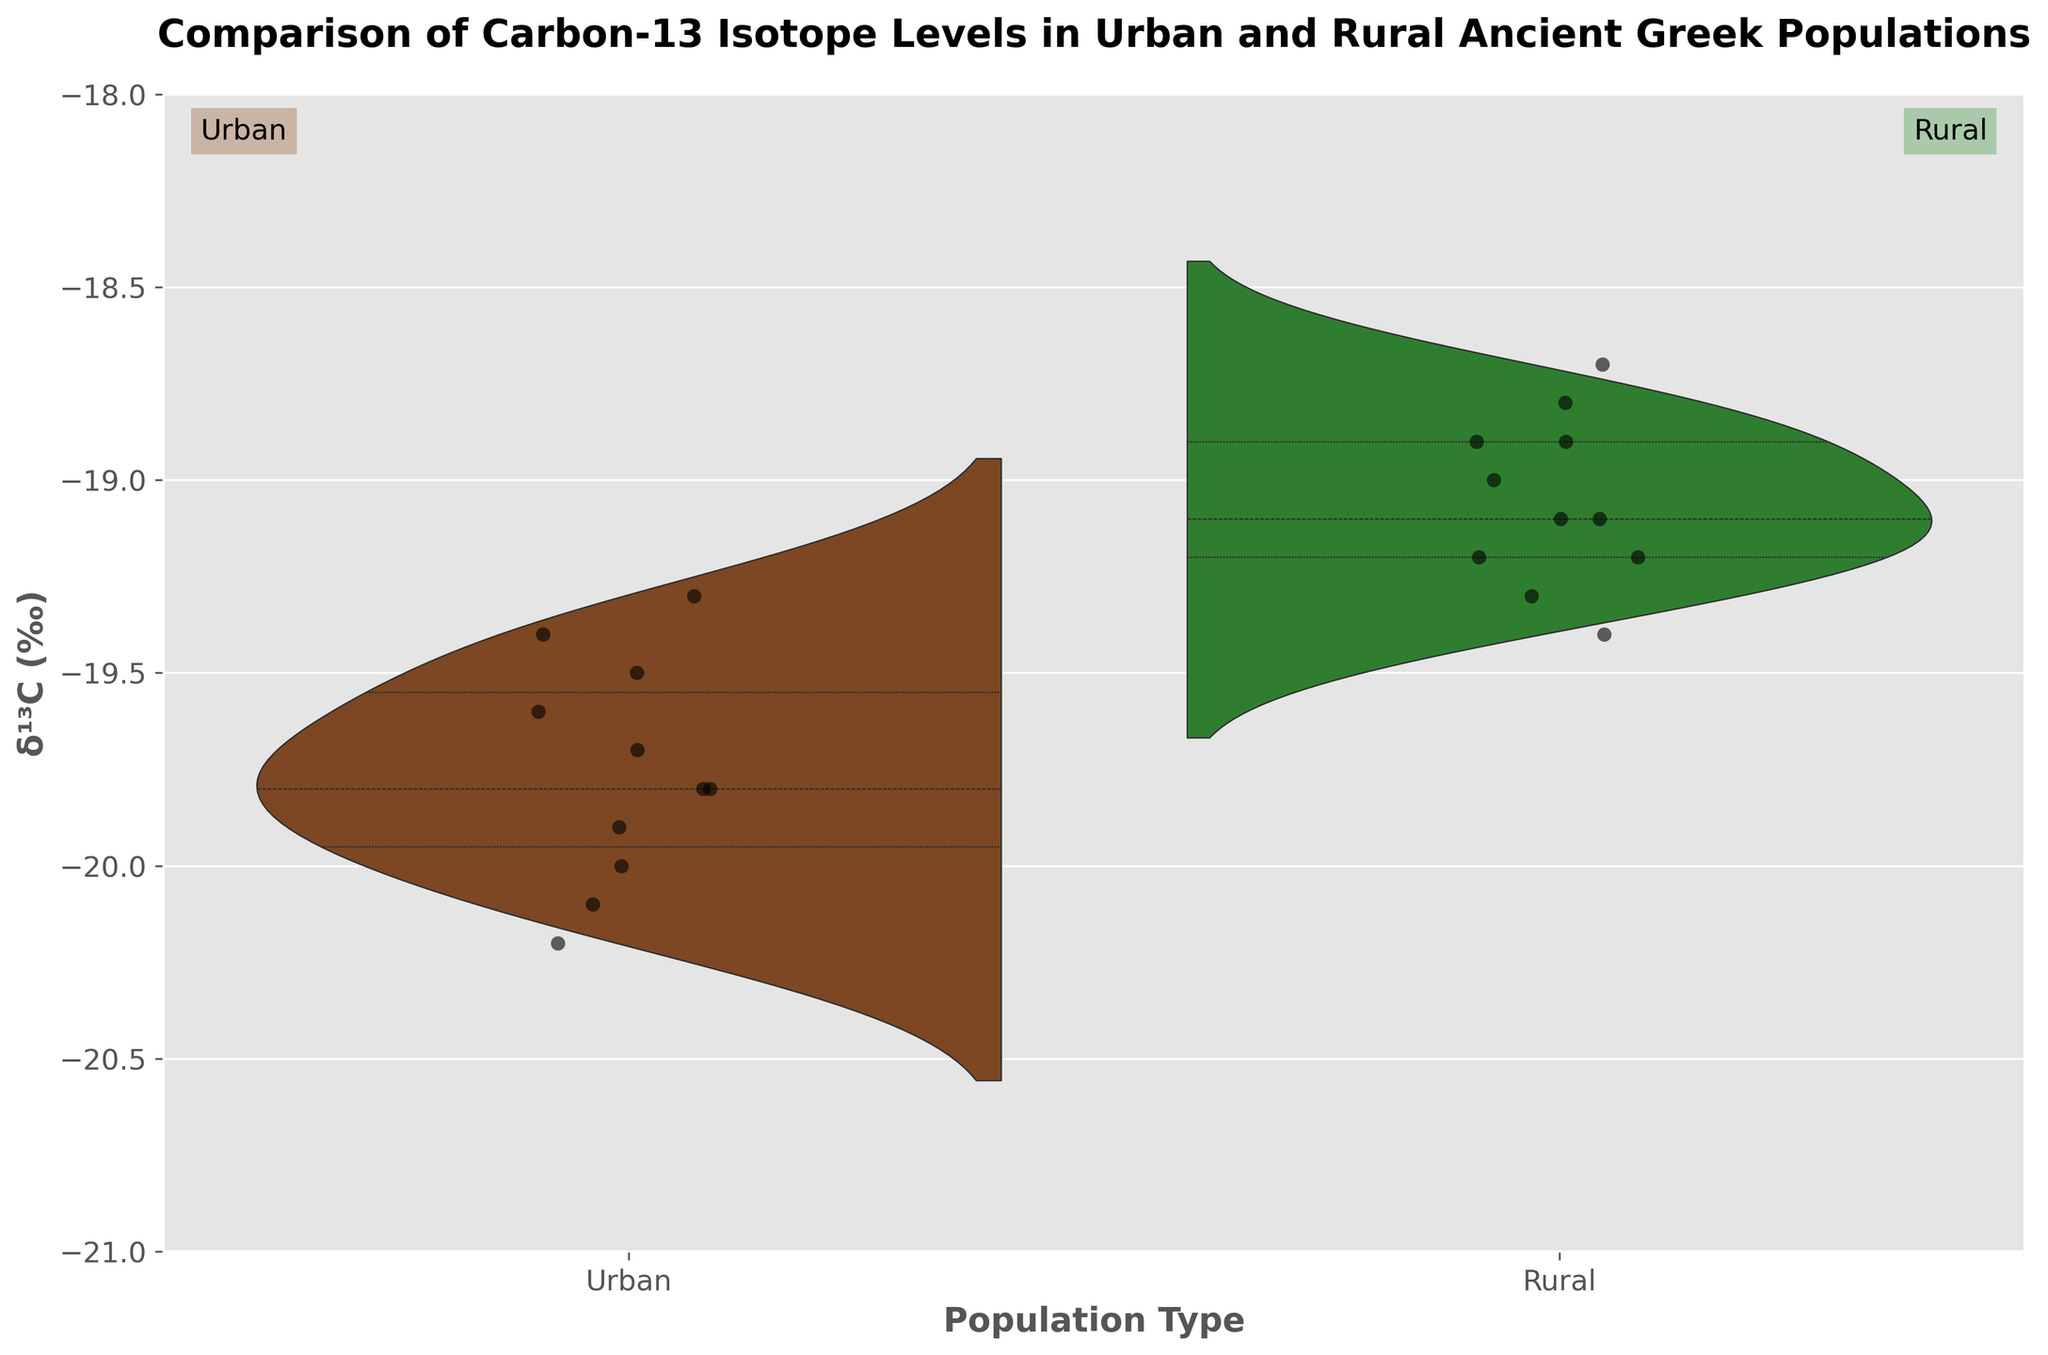What is the title of the figure? The title is found at the top of the figure and provides a summary of what the plot is about. In this case, the title is a textual description.
Answer: Comparison of Carbon-13 Isotope Levels in Urban and Rural Ancient Greek Populations What does the y-axis represent? The y-axis typically represents one of the variables being measured in the figure. In this case, it is labeled with the measurement unit.
Answer: δ¹³C (‰) What are the values of Carbon-13 isotope levels for the sample Corinth_02? To find this, locate the sample Corinth_02 under the 'Urban' group. The target values should be listed beside the sample ID.
Answer: -19.7 What color represents the urban population in the plot? Different color schemes in the figure represent different groups. By looking at the urban label and corresponding color, you can determine the color used.
Answer: Brown What are the highest and lowest Carbon-13 isotope levels in the rural population? To find these, look at the range of the 'Rural' sample in the violin plot and identify the extreme values.
Answer: Highest: -18.7; Lowest: -19.4 Which population type, urban or rural, shows a greater spread in Carbon-13 isotope levels? Compare the ranges seen in the split violin plots for both the 'Urban' and 'Rural' populations. The greater the spread, the wider and more dispersed the plot appears.
Answer: Urban By roughly how much is the average Carbon-13 isotope level of the urban population different from that of the rural population? Estimate the central values (means/medians) from the split violin plots of both populations. This involves visually comparing the central tendencies of each plot segment.
Answer: About 0.5‰ higher in rural Which population has a stronger central tendency for Carbon-13 isotope levels? A stronger central tendency is shown by having more data points clustered toward the middle of the distribution. This can be visualized by checking the density of points near the center of each split violin plot.
Answer: Rural Are there any outliers in the Carbon-13 isotope levels for either population? Outliers are typically shown as individual points separated from the main bulk of data. Look for any isolated points outside the general distribution in either section of the split violin plots.
Answer: No 